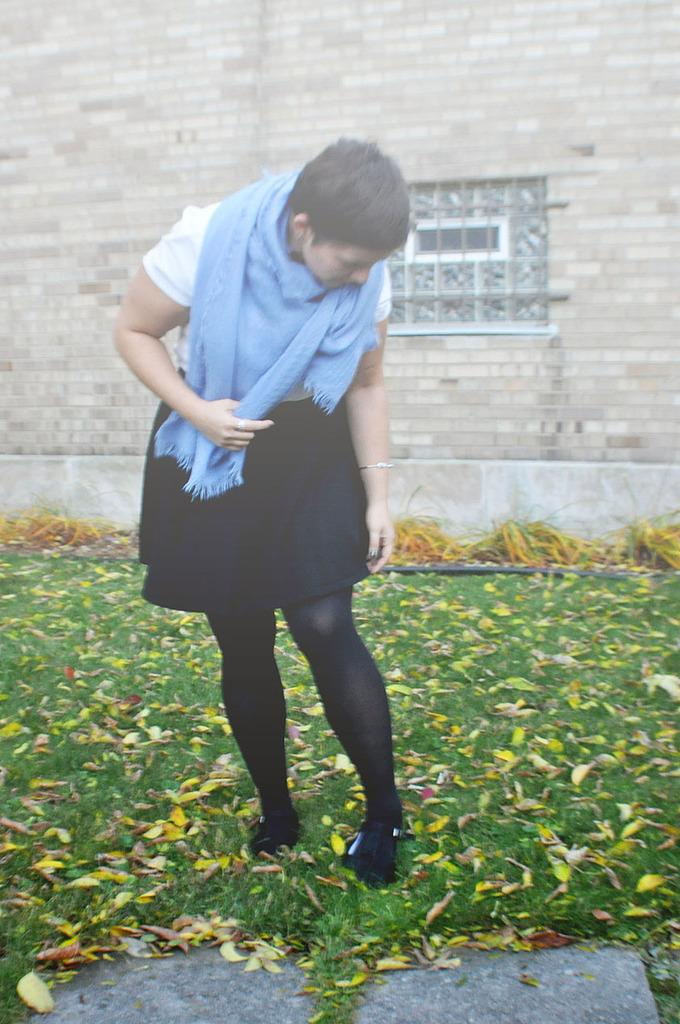Who is present in the image? There is a woman in the image. What is the woman standing on? The woman is standing on the grass. What can be seen behind the woman? There is a wall behind the woman. What type of dust can be seen on the woman's shoes in the image? There is no dust visible on the woman's shoes in the image. What kind of polish is the woman applying to the wall in the image? The woman is not applying any polish to the wall in the image. 